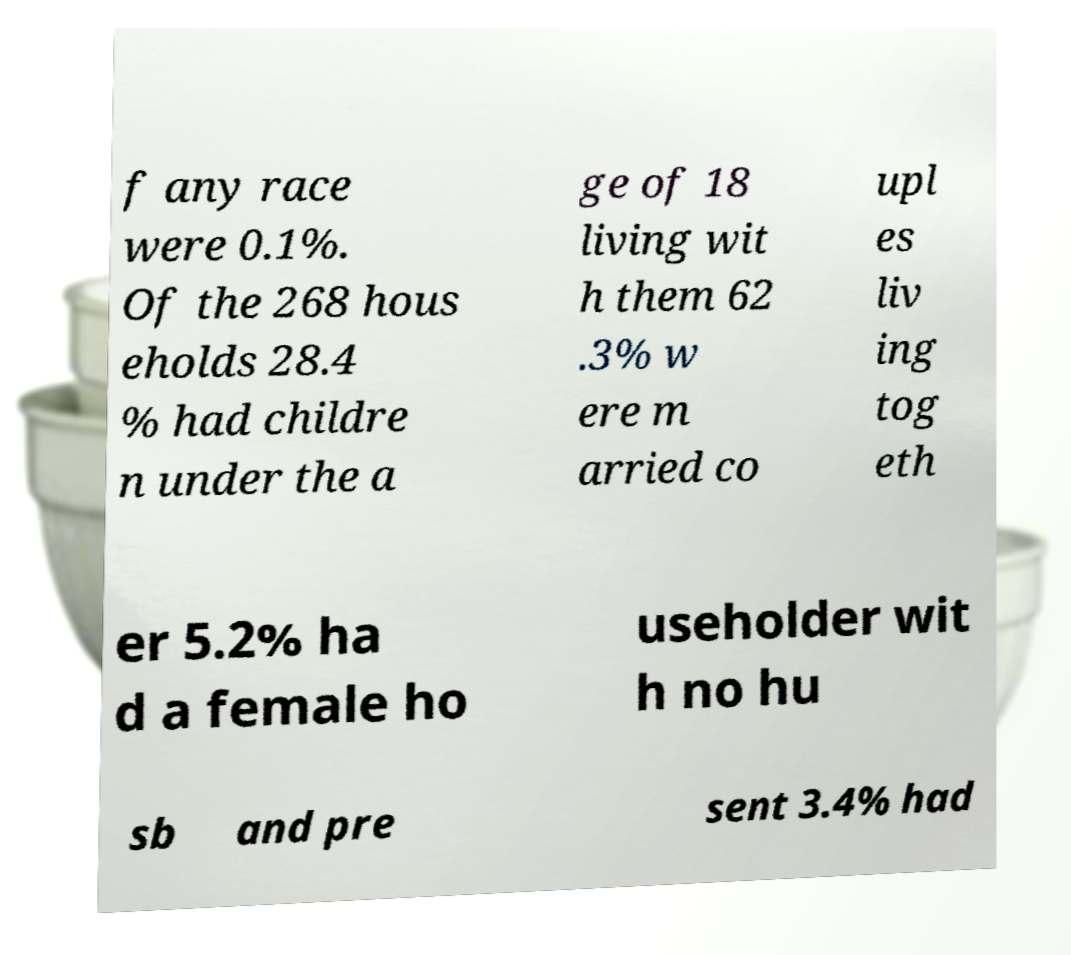Please read and relay the text visible in this image. What does it say? f any race were 0.1%. Of the 268 hous eholds 28.4 % had childre n under the a ge of 18 living wit h them 62 .3% w ere m arried co upl es liv ing tog eth er 5.2% ha d a female ho useholder wit h no hu sb and pre sent 3.4% had 